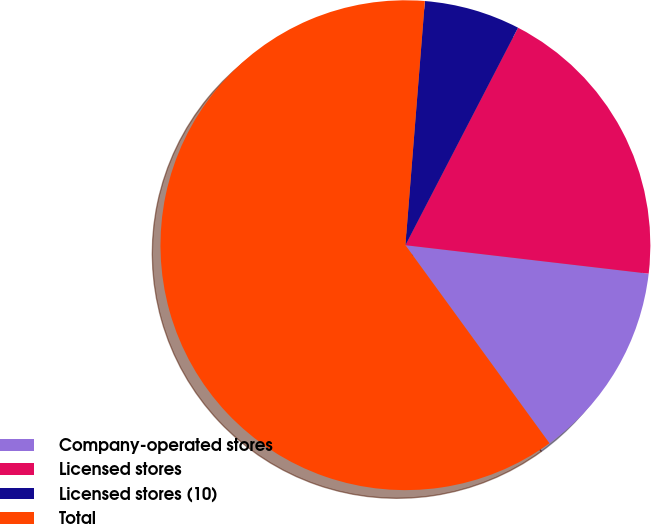Convert chart to OTSL. <chart><loc_0><loc_0><loc_500><loc_500><pie_chart><fcel>Company-operated stores<fcel>Licensed stores<fcel>Licensed stores (10)<fcel>Total<nl><fcel>13.14%<fcel>19.25%<fcel>6.34%<fcel>61.28%<nl></chart> 